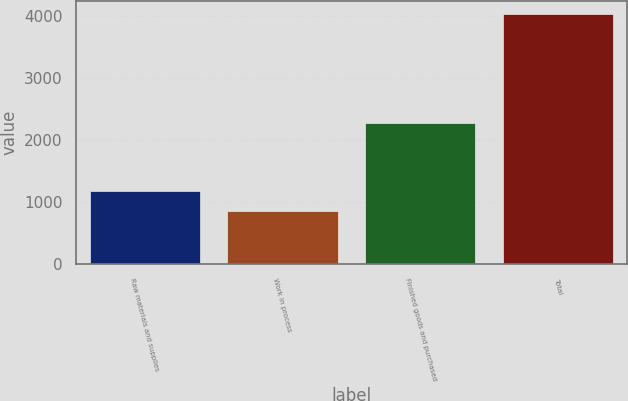Convert chart. <chart><loc_0><loc_0><loc_500><loc_500><bar_chart><fcel>Raw materials and supplies<fcel>Work in process<fcel>Finished goods and purchased<fcel>Total<nl><fcel>1169.8<fcel>852<fcel>2271<fcel>4030<nl></chart> 